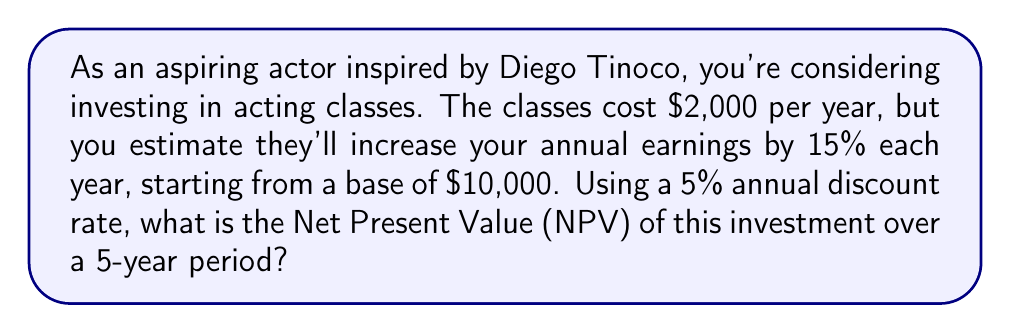Can you solve this math problem? Let's approach this step-by-step:

1) First, let's calculate the increased earnings for each year:
   Year 1: $10,000 * 1.15 = $11,500
   Year 2: $11,500 * 1.15 = $13,225
   Year 3: $13,225 * 1.15 = $15,208.75
   Year 4: $15,208.75 * 1.15 = $17,490.06
   Year 5: $17,490.06 * 1.15 = $20,113.57

2) Now, let's calculate the net cash flow for each year (increased earnings minus cost of classes):
   Year 1: $11,500 - $2,000 = $9,500
   Year 2: $13,225 - $2,000 = $11,225
   Year 3: $15,208.75 - $2,000 = $13,208.75
   Year 4: $17,490.06 - $2,000 = $15,490.06
   Year 5: $20,113.57 - $2,000 = $18,113.57

3) To calculate the NPV, we need to discount each year's net cash flow to present value and sum them up. The formula for present value is:

   $$ PV = \frac{FV}{(1+r)^n} $$

   Where FV is future value, r is discount rate, and n is number of years.

4) Let's calculate the present value for each year:
   Year 1: $\frac{9,500}{(1+0.05)^1} = 9,047.62$
   Year 2: $\frac{11,225}{(1+0.05)^2} = 10,181.97$
   Year 3: $\frac{13,208.75}{(1+0.05)^3} = 11,406.31$
   Year 4: $\frac{15,490.06}{(1+0.05)^4} = 12,724.63$
   Year 5: $\frac{18,113.57}{(1+0.05)^5} = 14,141.83$

5) The NPV is the sum of these present values:
   $$ NPV = 9,047.62 + 10,181.97 + 11,406.31 + 12,724.63 + 14,141.83 = 57,502.36 $$
Answer: $57,502.36 